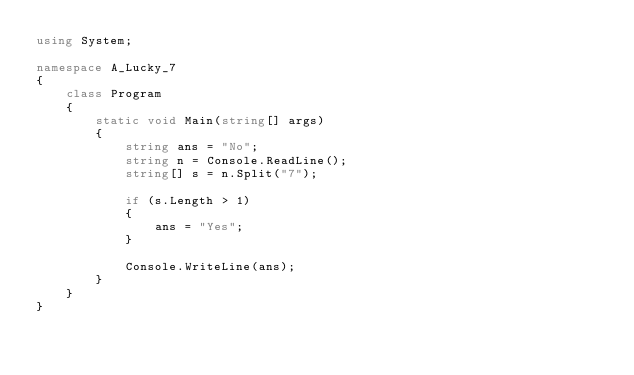Convert code to text. <code><loc_0><loc_0><loc_500><loc_500><_C#_>using System;

namespace A_Lucky_7
{
    class Program
    {
        static void Main(string[] args)
        {
            string ans = "No";
            string n = Console.ReadLine();
            string[] s = n.Split("7");
            
            if (s.Length > 1)
            {
                ans = "Yes";
            }
            
            Console.WriteLine(ans);
        }
    }
}
</code> 